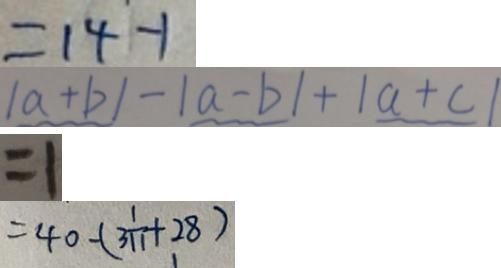Convert formula to latex. <formula><loc_0><loc_0><loc_500><loc_500>= 1 4 - 1 
 \vert a + b \vert - \vert a - b \vert + \vert a + c \vert 
 = 1 
 = 4 0 + ( 3 \frac { 1 } { 1 1 } + 2 8 )</formula> 